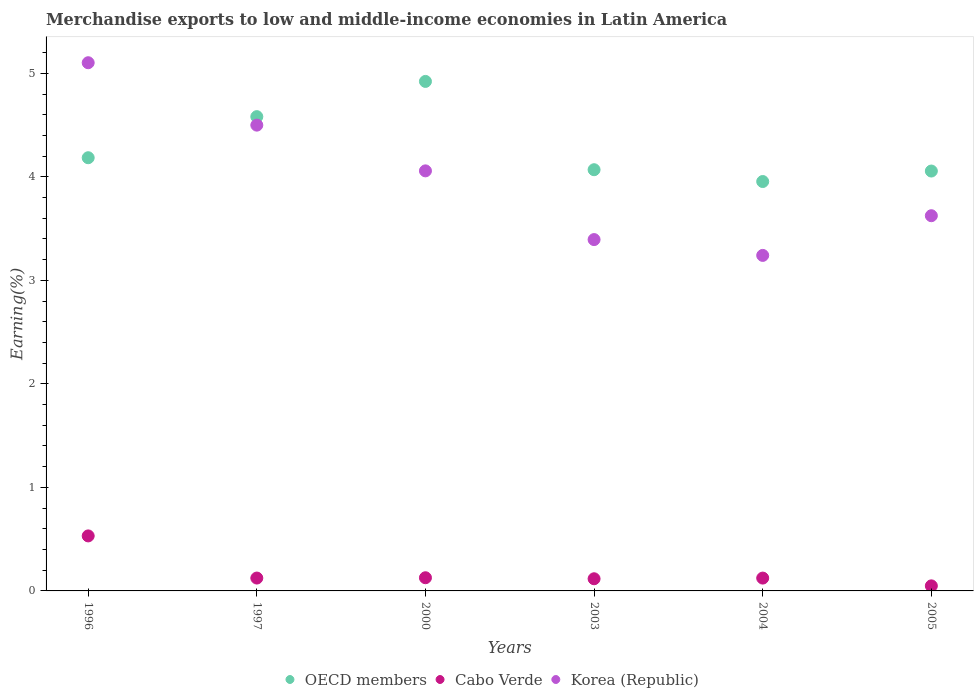How many different coloured dotlines are there?
Offer a terse response. 3. What is the percentage of amount earned from merchandise exports in Cabo Verde in 2003?
Offer a very short reply. 0.12. Across all years, what is the maximum percentage of amount earned from merchandise exports in OECD members?
Offer a very short reply. 4.92. Across all years, what is the minimum percentage of amount earned from merchandise exports in Korea (Republic)?
Your response must be concise. 3.24. In which year was the percentage of amount earned from merchandise exports in Cabo Verde minimum?
Keep it short and to the point. 2005. What is the total percentage of amount earned from merchandise exports in OECD members in the graph?
Your response must be concise. 25.77. What is the difference between the percentage of amount earned from merchandise exports in Cabo Verde in 1996 and that in 2000?
Provide a short and direct response. 0.4. What is the difference between the percentage of amount earned from merchandise exports in Cabo Verde in 1997 and the percentage of amount earned from merchandise exports in OECD members in 2000?
Keep it short and to the point. -4.8. What is the average percentage of amount earned from merchandise exports in Cabo Verde per year?
Give a very brief answer. 0.18. In the year 2003, what is the difference between the percentage of amount earned from merchandise exports in Korea (Republic) and percentage of amount earned from merchandise exports in Cabo Verde?
Your answer should be very brief. 3.28. In how many years, is the percentage of amount earned from merchandise exports in OECD members greater than 4.6 %?
Keep it short and to the point. 1. What is the ratio of the percentage of amount earned from merchandise exports in Cabo Verde in 2000 to that in 2003?
Make the answer very short. 1.08. Is the difference between the percentage of amount earned from merchandise exports in Korea (Republic) in 1996 and 1997 greater than the difference between the percentage of amount earned from merchandise exports in Cabo Verde in 1996 and 1997?
Make the answer very short. Yes. What is the difference between the highest and the second highest percentage of amount earned from merchandise exports in Korea (Republic)?
Keep it short and to the point. 0.6. What is the difference between the highest and the lowest percentage of amount earned from merchandise exports in Korea (Republic)?
Provide a succinct answer. 1.86. Is it the case that in every year, the sum of the percentage of amount earned from merchandise exports in Korea (Republic) and percentage of amount earned from merchandise exports in Cabo Verde  is greater than the percentage of amount earned from merchandise exports in OECD members?
Offer a terse response. No. Does the percentage of amount earned from merchandise exports in Korea (Republic) monotonically increase over the years?
Offer a terse response. No. Is the percentage of amount earned from merchandise exports in Cabo Verde strictly greater than the percentage of amount earned from merchandise exports in OECD members over the years?
Ensure brevity in your answer.  No. Is the percentage of amount earned from merchandise exports in OECD members strictly less than the percentage of amount earned from merchandise exports in Korea (Republic) over the years?
Keep it short and to the point. No. How many dotlines are there?
Your answer should be very brief. 3. Where does the legend appear in the graph?
Offer a terse response. Bottom center. How many legend labels are there?
Make the answer very short. 3. How are the legend labels stacked?
Offer a very short reply. Horizontal. What is the title of the graph?
Provide a succinct answer. Merchandise exports to low and middle-income economies in Latin America. What is the label or title of the X-axis?
Your answer should be very brief. Years. What is the label or title of the Y-axis?
Provide a succinct answer. Earning(%). What is the Earning(%) in OECD members in 1996?
Keep it short and to the point. 4.18. What is the Earning(%) of Cabo Verde in 1996?
Offer a very short reply. 0.53. What is the Earning(%) of Korea (Republic) in 1996?
Offer a very short reply. 5.1. What is the Earning(%) of OECD members in 1997?
Provide a short and direct response. 4.58. What is the Earning(%) in Cabo Verde in 1997?
Give a very brief answer. 0.12. What is the Earning(%) in Korea (Republic) in 1997?
Give a very brief answer. 4.5. What is the Earning(%) in OECD members in 2000?
Your answer should be compact. 4.92. What is the Earning(%) of Cabo Verde in 2000?
Provide a succinct answer. 0.13. What is the Earning(%) in Korea (Republic) in 2000?
Keep it short and to the point. 4.06. What is the Earning(%) of OECD members in 2003?
Your response must be concise. 4.07. What is the Earning(%) in Cabo Verde in 2003?
Keep it short and to the point. 0.12. What is the Earning(%) of Korea (Republic) in 2003?
Your answer should be compact. 3.39. What is the Earning(%) in OECD members in 2004?
Provide a short and direct response. 3.95. What is the Earning(%) in Cabo Verde in 2004?
Make the answer very short. 0.12. What is the Earning(%) of Korea (Republic) in 2004?
Provide a succinct answer. 3.24. What is the Earning(%) of OECD members in 2005?
Make the answer very short. 4.06. What is the Earning(%) in Cabo Verde in 2005?
Offer a terse response. 0.05. What is the Earning(%) in Korea (Republic) in 2005?
Make the answer very short. 3.62. Across all years, what is the maximum Earning(%) of OECD members?
Your answer should be very brief. 4.92. Across all years, what is the maximum Earning(%) of Cabo Verde?
Provide a succinct answer. 0.53. Across all years, what is the maximum Earning(%) in Korea (Republic)?
Give a very brief answer. 5.1. Across all years, what is the minimum Earning(%) in OECD members?
Your response must be concise. 3.95. Across all years, what is the minimum Earning(%) in Cabo Verde?
Keep it short and to the point. 0.05. Across all years, what is the minimum Earning(%) of Korea (Republic)?
Provide a short and direct response. 3.24. What is the total Earning(%) in OECD members in the graph?
Your answer should be compact. 25.77. What is the total Earning(%) in Cabo Verde in the graph?
Your answer should be very brief. 1.07. What is the total Earning(%) in Korea (Republic) in the graph?
Give a very brief answer. 23.92. What is the difference between the Earning(%) of OECD members in 1996 and that in 1997?
Provide a short and direct response. -0.4. What is the difference between the Earning(%) in Cabo Verde in 1996 and that in 1997?
Offer a terse response. 0.41. What is the difference between the Earning(%) in Korea (Republic) in 1996 and that in 1997?
Make the answer very short. 0.6. What is the difference between the Earning(%) of OECD members in 1996 and that in 2000?
Ensure brevity in your answer.  -0.74. What is the difference between the Earning(%) of Cabo Verde in 1996 and that in 2000?
Your response must be concise. 0.4. What is the difference between the Earning(%) in Korea (Republic) in 1996 and that in 2000?
Provide a short and direct response. 1.04. What is the difference between the Earning(%) of OECD members in 1996 and that in 2003?
Keep it short and to the point. 0.12. What is the difference between the Earning(%) of Cabo Verde in 1996 and that in 2003?
Your answer should be very brief. 0.41. What is the difference between the Earning(%) in Korea (Republic) in 1996 and that in 2003?
Offer a very short reply. 1.71. What is the difference between the Earning(%) of OECD members in 1996 and that in 2004?
Offer a very short reply. 0.23. What is the difference between the Earning(%) in Cabo Verde in 1996 and that in 2004?
Provide a short and direct response. 0.41. What is the difference between the Earning(%) of Korea (Republic) in 1996 and that in 2004?
Your answer should be very brief. 1.86. What is the difference between the Earning(%) in OECD members in 1996 and that in 2005?
Offer a very short reply. 0.13. What is the difference between the Earning(%) in Cabo Verde in 1996 and that in 2005?
Give a very brief answer. 0.48. What is the difference between the Earning(%) of Korea (Republic) in 1996 and that in 2005?
Ensure brevity in your answer.  1.48. What is the difference between the Earning(%) in OECD members in 1997 and that in 2000?
Offer a very short reply. -0.34. What is the difference between the Earning(%) of Cabo Verde in 1997 and that in 2000?
Offer a terse response. -0. What is the difference between the Earning(%) in Korea (Republic) in 1997 and that in 2000?
Provide a short and direct response. 0.44. What is the difference between the Earning(%) of OECD members in 1997 and that in 2003?
Provide a succinct answer. 0.51. What is the difference between the Earning(%) of Cabo Verde in 1997 and that in 2003?
Your answer should be compact. 0.01. What is the difference between the Earning(%) in Korea (Republic) in 1997 and that in 2003?
Offer a terse response. 1.11. What is the difference between the Earning(%) of OECD members in 1997 and that in 2004?
Offer a very short reply. 0.63. What is the difference between the Earning(%) in Korea (Republic) in 1997 and that in 2004?
Ensure brevity in your answer.  1.26. What is the difference between the Earning(%) of OECD members in 1997 and that in 2005?
Provide a short and direct response. 0.53. What is the difference between the Earning(%) in Cabo Verde in 1997 and that in 2005?
Your answer should be compact. 0.08. What is the difference between the Earning(%) in Korea (Republic) in 1997 and that in 2005?
Give a very brief answer. 0.88. What is the difference between the Earning(%) in OECD members in 2000 and that in 2003?
Offer a very short reply. 0.85. What is the difference between the Earning(%) in Cabo Verde in 2000 and that in 2003?
Make the answer very short. 0.01. What is the difference between the Earning(%) of Korea (Republic) in 2000 and that in 2003?
Offer a terse response. 0.66. What is the difference between the Earning(%) in OECD members in 2000 and that in 2004?
Provide a succinct answer. 0.97. What is the difference between the Earning(%) in Cabo Verde in 2000 and that in 2004?
Your response must be concise. 0. What is the difference between the Earning(%) of Korea (Republic) in 2000 and that in 2004?
Offer a very short reply. 0.82. What is the difference between the Earning(%) of OECD members in 2000 and that in 2005?
Offer a terse response. 0.87. What is the difference between the Earning(%) of Cabo Verde in 2000 and that in 2005?
Provide a succinct answer. 0.08. What is the difference between the Earning(%) in Korea (Republic) in 2000 and that in 2005?
Make the answer very short. 0.43. What is the difference between the Earning(%) of OECD members in 2003 and that in 2004?
Make the answer very short. 0.11. What is the difference between the Earning(%) in Cabo Verde in 2003 and that in 2004?
Offer a terse response. -0.01. What is the difference between the Earning(%) in Korea (Republic) in 2003 and that in 2004?
Your answer should be very brief. 0.15. What is the difference between the Earning(%) in OECD members in 2003 and that in 2005?
Your response must be concise. 0.01. What is the difference between the Earning(%) in Cabo Verde in 2003 and that in 2005?
Your answer should be compact. 0.07. What is the difference between the Earning(%) of Korea (Republic) in 2003 and that in 2005?
Keep it short and to the point. -0.23. What is the difference between the Earning(%) of OECD members in 2004 and that in 2005?
Give a very brief answer. -0.1. What is the difference between the Earning(%) of Cabo Verde in 2004 and that in 2005?
Offer a very short reply. 0.08. What is the difference between the Earning(%) of Korea (Republic) in 2004 and that in 2005?
Ensure brevity in your answer.  -0.38. What is the difference between the Earning(%) in OECD members in 1996 and the Earning(%) in Cabo Verde in 1997?
Your response must be concise. 4.06. What is the difference between the Earning(%) of OECD members in 1996 and the Earning(%) of Korea (Republic) in 1997?
Your response must be concise. -0.31. What is the difference between the Earning(%) of Cabo Verde in 1996 and the Earning(%) of Korea (Republic) in 1997?
Give a very brief answer. -3.97. What is the difference between the Earning(%) in OECD members in 1996 and the Earning(%) in Cabo Verde in 2000?
Offer a terse response. 4.06. What is the difference between the Earning(%) in OECD members in 1996 and the Earning(%) in Korea (Republic) in 2000?
Offer a terse response. 0.13. What is the difference between the Earning(%) in Cabo Verde in 1996 and the Earning(%) in Korea (Republic) in 2000?
Your answer should be compact. -3.53. What is the difference between the Earning(%) of OECD members in 1996 and the Earning(%) of Cabo Verde in 2003?
Provide a short and direct response. 4.07. What is the difference between the Earning(%) in OECD members in 1996 and the Earning(%) in Korea (Republic) in 2003?
Keep it short and to the point. 0.79. What is the difference between the Earning(%) in Cabo Verde in 1996 and the Earning(%) in Korea (Republic) in 2003?
Ensure brevity in your answer.  -2.86. What is the difference between the Earning(%) of OECD members in 1996 and the Earning(%) of Cabo Verde in 2004?
Provide a succinct answer. 4.06. What is the difference between the Earning(%) of OECD members in 1996 and the Earning(%) of Korea (Republic) in 2004?
Give a very brief answer. 0.94. What is the difference between the Earning(%) of Cabo Verde in 1996 and the Earning(%) of Korea (Republic) in 2004?
Your answer should be very brief. -2.71. What is the difference between the Earning(%) of OECD members in 1996 and the Earning(%) of Cabo Verde in 2005?
Give a very brief answer. 4.14. What is the difference between the Earning(%) in OECD members in 1996 and the Earning(%) in Korea (Republic) in 2005?
Offer a very short reply. 0.56. What is the difference between the Earning(%) in Cabo Verde in 1996 and the Earning(%) in Korea (Republic) in 2005?
Offer a very short reply. -3.09. What is the difference between the Earning(%) of OECD members in 1997 and the Earning(%) of Cabo Verde in 2000?
Your answer should be compact. 4.45. What is the difference between the Earning(%) of OECD members in 1997 and the Earning(%) of Korea (Republic) in 2000?
Your answer should be very brief. 0.52. What is the difference between the Earning(%) of Cabo Verde in 1997 and the Earning(%) of Korea (Republic) in 2000?
Offer a very short reply. -3.93. What is the difference between the Earning(%) of OECD members in 1997 and the Earning(%) of Cabo Verde in 2003?
Give a very brief answer. 4.46. What is the difference between the Earning(%) of OECD members in 1997 and the Earning(%) of Korea (Republic) in 2003?
Provide a short and direct response. 1.19. What is the difference between the Earning(%) in Cabo Verde in 1997 and the Earning(%) in Korea (Republic) in 2003?
Offer a very short reply. -3.27. What is the difference between the Earning(%) in OECD members in 1997 and the Earning(%) in Cabo Verde in 2004?
Ensure brevity in your answer.  4.46. What is the difference between the Earning(%) in OECD members in 1997 and the Earning(%) in Korea (Republic) in 2004?
Your response must be concise. 1.34. What is the difference between the Earning(%) of Cabo Verde in 1997 and the Earning(%) of Korea (Republic) in 2004?
Provide a succinct answer. -3.12. What is the difference between the Earning(%) of OECD members in 1997 and the Earning(%) of Cabo Verde in 2005?
Offer a very short reply. 4.53. What is the difference between the Earning(%) of Cabo Verde in 1997 and the Earning(%) of Korea (Republic) in 2005?
Give a very brief answer. -3.5. What is the difference between the Earning(%) in OECD members in 2000 and the Earning(%) in Cabo Verde in 2003?
Offer a very short reply. 4.8. What is the difference between the Earning(%) in OECD members in 2000 and the Earning(%) in Korea (Republic) in 2003?
Provide a short and direct response. 1.53. What is the difference between the Earning(%) of Cabo Verde in 2000 and the Earning(%) of Korea (Republic) in 2003?
Your answer should be compact. -3.27. What is the difference between the Earning(%) in OECD members in 2000 and the Earning(%) in Cabo Verde in 2004?
Your answer should be very brief. 4.8. What is the difference between the Earning(%) of OECD members in 2000 and the Earning(%) of Korea (Republic) in 2004?
Keep it short and to the point. 1.68. What is the difference between the Earning(%) in Cabo Verde in 2000 and the Earning(%) in Korea (Republic) in 2004?
Make the answer very short. -3.11. What is the difference between the Earning(%) in OECD members in 2000 and the Earning(%) in Cabo Verde in 2005?
Offer a terse response. 4.87. What is the difference between the Earning(%) of OECD members in 2000 and the Earning(%) of Korea (Republic) in 2005?
Make the answer very short. 1.3. What is the difference between the Earning(%) in Cabo Verde in 2000 and the Earning(%) in Korea (Republic) in 2005?
Keep it short and to the point. -3.5. What is the difference between the Earning(%) of OECD members in 2003 and the Earning(%) of Cabo Verde in 2004?
Ensure brevity in your answer.  3.94. What is the difference between the Earning(%) of OECD members in 2003 and the Earning(%) of Korea (Republic) in 2004?
Your response must be concise. 0.83. What is the difference between the Earning(%) of Cabo Verde in 2003 and the Earning(%) of Korea (Republic) in 2004?
Your answer should be very brief. -3.12. What is the difference between the Earning(%) in OECD members in 2003 and the Earning(%) in Cabo Verde in 2005?
Make the answer very short. 4.02. What is the difference between the Earning(%) of OECD members in 2003 and the Earning(%) of Korea (Republic) in 2005?
Your answer should be compact. 0.44. What is the difference between the Earning(%) in Cabo Verde in 2003 and the Earning(%) in Korea (Republic) in 2005?
Offer a very short reply. -3.51. What is the difference between the Earning(%) in OECD members in 2004 and the Earning(%) in Cabo Verde in 2005?
Offer a very short reply. 3.91. What is the difference between the Earning(%) of OECD members in 2004 and the Earning(%) of Korea (Republic) in 2005?
Offer a very short reply. 0.33. What is the difference between the Earning(%) in Cabo Verde in 2004 and the Earning(%) in Korea (Republic) in 2005?
Offer a very short reply. -3.5. What is the average Earning(%) of OECD members per year?
Make the answer very short. 4.29. What is the average Earning(%) of Cabo Verde per year?
Your answer should be very brief. 0.18. What is the average Earning(%) of Korea (Republic) per year?
Offer a very short reply. 3.99. In the year 1996, what is the difference between the Earning(%) in OECD members and Earning(%) in Cabo Verde?
Offer a terse response. 3.65. In the year 1996, what is the difference between the Earning(%) of OECD members and Earning(%) of Korea (Republic)?
Keep it short and to the point. -0.92. In the year 1996, what is the difference between the Earning(%) in Cabo Verde and Earning(%) in Korea (Republic)?
Ensure brevity in your answer.  -4.57. In the year 1997, what is the difference between the Earning(%) in OECD members and Earning(%) in Cabo Verde?
Your response must be concise. 4.46. In the year 1997, what is the difference between the Earning(%) in OECD members and Earning(%) in Korea (Republic)?
Offer a terse response. 0.08. In the year 1997, what is the difference between the Earning(%) in Cabo Verde and Earning(%) in Korea (Republic)?
Ensure brevity in your answer.  -4.38. In the year 2000, what is the difference between the Earning(%) of OECD members and Earning(%) of Cabo Verde?
Your answer should be compact. 4.79. In the year 2000, what is the difference between the Earning(%) of OECD members and Earning(%) of Korea (Republic)?
Your response must be concise. 0.86. In the year 2000, what is the difference between the Earning(%) in Cabo Verde and Earning(%) in Korea (Republic)?
Give a very brief answer. -3.93. In the year 2003, what is the difference between the Earning(%) of OECD members and Earning(%) of Cabo Verde?
Your answer should be compact. 3.95. In the year 2003, what is the difference between the Earning(%) in OECD members and Earning(%) in Korea (Republic)?
Your response must be concise. 0.67. In the year 2003, what is the difference between the Earning(%) in Cabo Verde and Earning(%) in Korea (Republic)?
Ensure brevity in your answer.  -3.28. In the year 2004, what is the difference between the Earning(%) in OECD members and Earning(%) in Cabo Verde?
Ensure brevity in your answer.  3.83. In the year 2004, what is the difference between the Earning(%) in OECD members and Earning(%) in Korea (Republic)?
Provide a succinct answer. 0.71. In the year 2004, what is the difference between the Earning(%) of Cabo Verde and Earning(%) of Korea (Republic)?
Provide a short and direct response. -3.12. In the year 2005, what is the difference between the Earning(%) of OECD members and Earning(%) of Cabo Verde?
Your response must be concise. 4.01. In the year 2005, what is the difference between the Earning(%) in OECD members and Earning(%) in Korea (Republic)?
Offer a terse response. 0.43. In the year 2005, what is the difference between the Earning(%) of Cabo Verde and Earning(%) of Korea (Republic)?
Provide a short and direct response. -3.58. What is the ratio of the Earning(%) of OECD members in 1996 to that in 1997?
Your answer should be compact. 0.91. What is the ratio of the Earning(%) of Cabo Verde in 1996 to that in 1997?
Provide a short and direct response. 4.28. What is the ratio of the Earning(%) of Korea (Republic) in 1996 to that in 1997?
Your response must be concise. 1.13. What is the ratio of the Earning(%) of OECD members in 1996 to that in 2000?
Offer a terse response. 0.85. What is the ratio of the Earning(%) in Cabo Verde in 1996 to that in 2000?
Offer a terse response. 4.18. What is the ratio of the Earning(%) of Korea (Republic) in 1996 to that in 2000?
Provide a succinct answer. 1.26. What is the ratio of the Earning(%) of OECD members in 1996 to that in 2003?
Give a very brief answer. 1.03. What is the ratio of the Earning(%) of Cabo Verde in 1996 to that in 2003?
Provide a succinct answer. 4.52. What is the ratio of the Earning(%) in Korea (Republic) in 1996 to that in 2003?
Your response must be concise. 1.5. What is the ratio of the Earning(%) of OECD members in 1996 to that in 2004?
Your answer should be compact. 1.06. What is the ratio of the Earning(%) of Cabo Verde in 1996 to that in 2004?
Provide a short and direct response. 4.29. What is the ratio of the Earning(%) in Korea (Republic) in 1996 to that in 2004?
Your answer should be very brief. 1.57. What is the ratio of the Earning(%) of OECD members in 1996 to that in 2005?
Make the answer very short. 1.03. What is the ratio of the Earning(%) of Cabo Verde in 1996 to that in 2005?
Provide a succinct answer. 10.87. What is the ratio of the Earning(%) in Korea (Republic) in 1996 to that in 2005?
Provide a short and direct response. 1.41. What is the ratio of the Earning(%) of OECD members in 1997 to that in 2000?
Provide a short and direct response. 0.93. What is the ratio of the Earning(%) of Cabo Verde in 1997 to that in 2000?
Your response must be concise. 0.98. What is the ratio of the Earning(%) in Korea (Republic) in 1997 to that in 2000?
Your answer should be very brief. 1.11. What is the ratio of the Earning(%) in OECD members in 1997 to that in 2003?
Your answer should be compact. 1.13. What is the ratio of the Earning(%) of Cabo Verde in 1997 to that in 2003?
Provide a short and direct response. 1.06. What is the ratio of the Earning(%) of Korea (Republic) in 1997 to that in 2003?
Ensure brevity in your answer.  1.33. What is the ratio of the Earning(%) in OECD members in 1997 to that in 2004?
Make the answer very short. 1.16. What is the ratio of the Earning(%) of Korea (Republic) in 1997 to that in 2004?
Your answer should be compact. 1.39. What is the ratio of the Earning(%) in OECD members in 1997 to that in 2005?
Offer a terse response. 1.13. What is the ratio of the Earning(%) in Cabo Verde in 1997 to that in 2005?
Offer a very short reply. 2.54. What is the ratio of the Earning(%) in Korea (Republic) in 1997 to that in 2005?
Your response must be concise. 1.24. What is the ratio of the Earning(%) of OECD members in 2000 to that in 2003?
Make the answer very short. 1.21. What is the ratio of the Earning(%) of Cabo Verde in 2000 to that in 2003?
Your answer should be very brief. 1.08. What is the ratio of the Earning(%) of Korea (Republic) in 2000 to that in 2003?
Offer a very short reply. 1.2. What is the ratio of the Earning(%) in OECD members in 2000 to that in 2004?
Ensure brevity in your answer.  1.24. What is the ratio of the Earning(%) of Cabo Verde in 2000 to that in 2004?
Give a very brief answer. 1.03. What is the ratio of the Earning(%) in Korea (Republic) in 2000 to that in 2004?
Your answer should be compact. 1.25. What is the ratio of the Earning(%) in OECD members in 2000 to that in 2005?
Make the answer very short. 1.21. What is the ratio of the Earning(%) of Cabo Verde in 2000 to that in 2005?
Provide a short and direct response. 2.6. What is the ratio of the Earning(%) in Korea (Republic) in 2000 to that in 2005?
Offer a very short reply. 1.12. What is the ratio of the Earning(%) of OECD members in 2003 to that in 2004?
Offer a terse response. 1.03. What is the ratio of the Earning(%) of Cabo Verde in 2003 to that in 2004?
Provide a succinct answer. 0.95. What is the ratio of the Earning(%) in Korea (Republic) in 2003 to that in 2004?
Your answer should be very brief. 1.05. What is the ratio of the Earning(%) of Cabo Verde in 2003 to that in 2005?
Ensure brevity in your answer.  2.4. What is the ratio of the Earning(%) in Korea (Republic) in 2003 to that in 2005?
Ensure brevity in your answer.  0.94. What is the ratio of the Earning(%) in OECD members in 2004 to that in 2005?
Provide a short and direct response. 0.97. What is the ratio of the Earning(%) in Cabo Verde in 2004 to that in 2005?
Ensure brevity in your answer.  2.54. What is the ratio of the Earning(%) in Korea (Republic) in 2004 to that in 2005?
Make the answer very short. 0.89. What is the difference between the highest and the second highest Earning(%) in OECD members?
Provide a succinct answer. 0.34. What is the difference between the highest and the second highest Earning(%) of Cabo Verde?
Your response must be concise. 0.4. What is the difference between the highest and the second highest Earning(%) in Korea (Republic)?
Give a very brief answer. 0.6. What is the difference between the highest and the lowest Earning(%) in OECD members?
Ensure brevity in your answer.  0.97. What is the difference between the highest and the lowest Earning(%) of Cabo Verde?
Keep it short and to the point. 0.48. What is the difference between the highest and the lowest Earning(%) of Korea (Republic)?
Your answer should be compact. 1.86. 